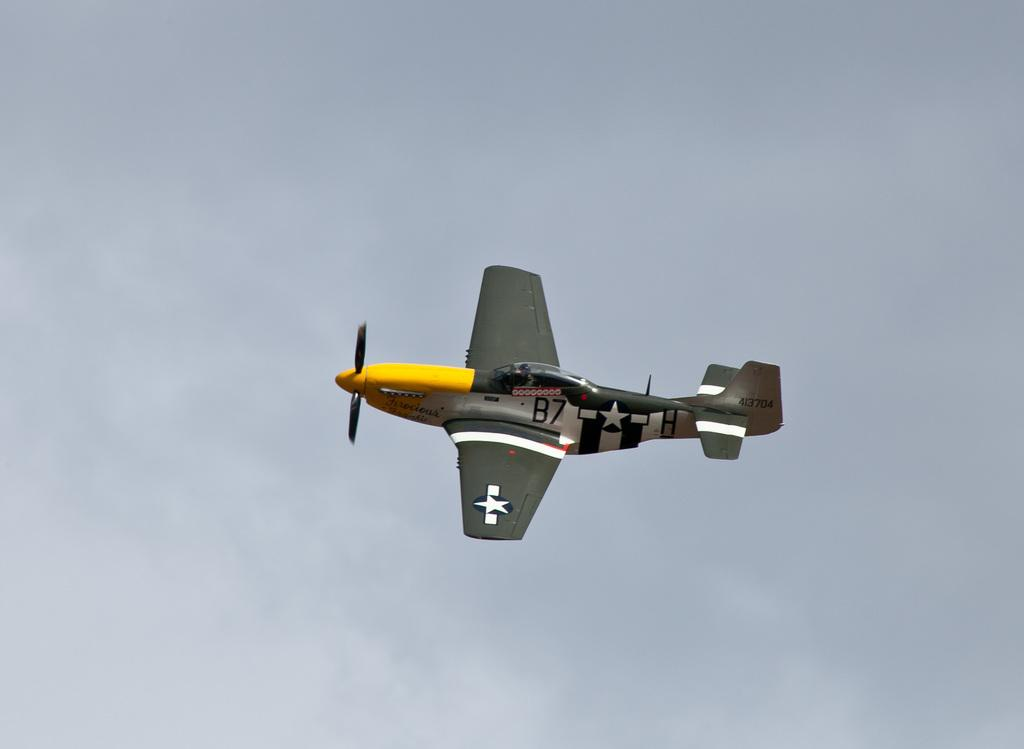Provide a one-sentence caption for the provided image. An American B-7 single propeller airplane in the sky. 